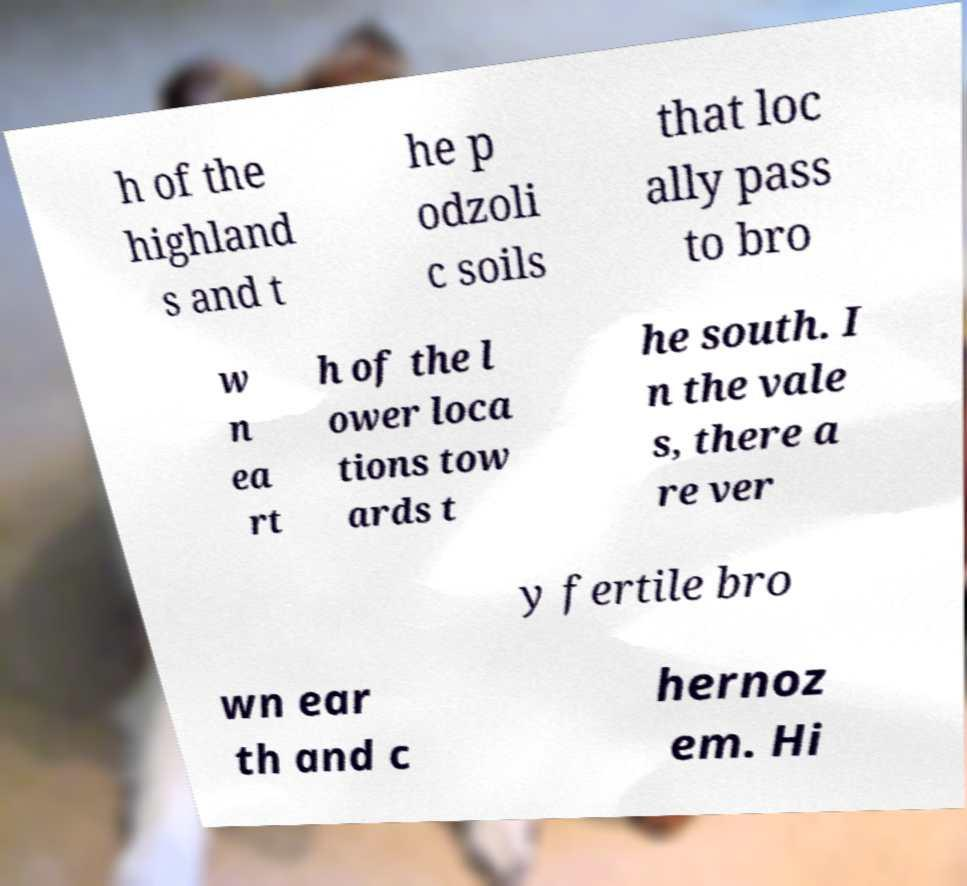Can you read and provide the text displayed in the image?This photo seems to have some interesting text. Can you extract and type it out for me? h of the highland s and t he p odzoli c soils that loc ally pass to bro w n ea rt h of the l ower loca tions tow ards t he south. I n the vale s, there a re ver y fertile bro wn ear th and c hernoz em. Hi 